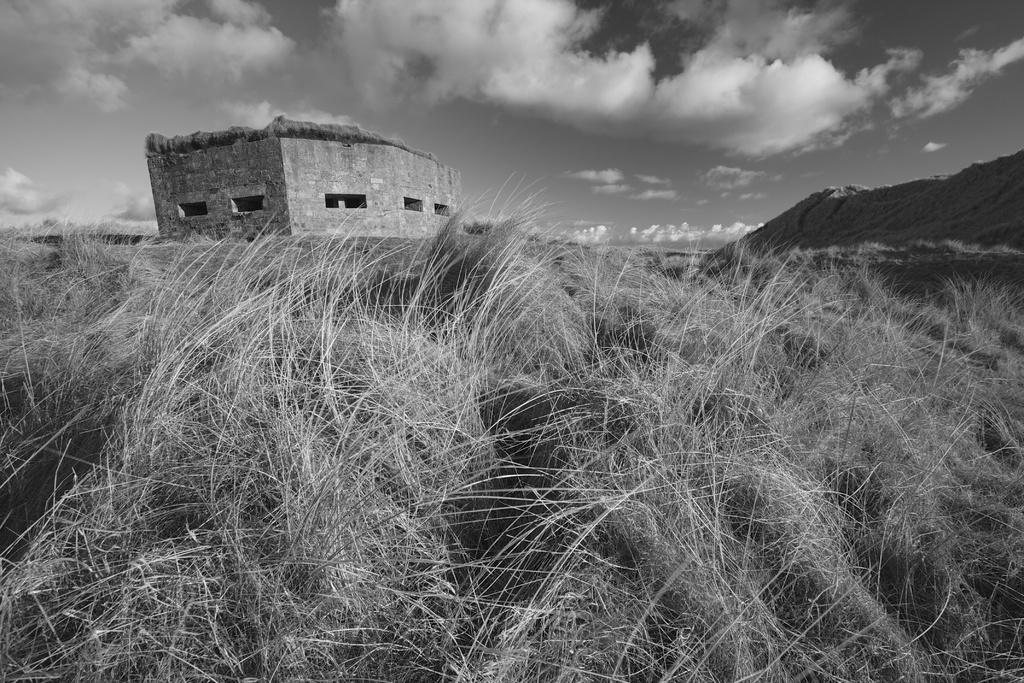What type of vegetation is present in the image? There is grass in the image. What can be seen in the background of the image? There is a building and a sand heap in the background of the image. What is visible in the sky in the image? Clouds and the sky are visible in the background of the image. What type of apparel is the grass wearing in the image? Grass does not wear apparel, as it is a plant and not a sentient being. 